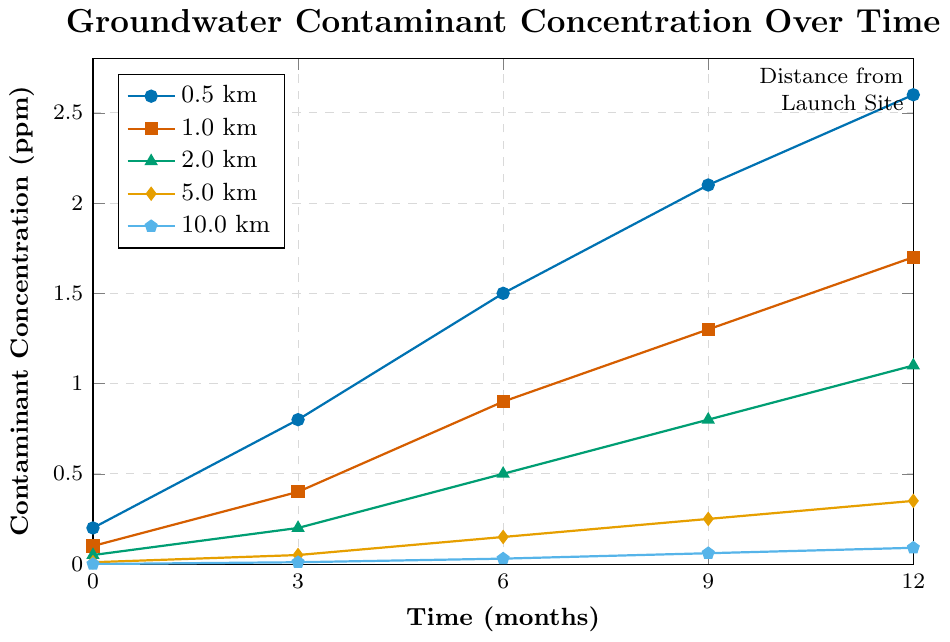What's the highest contaminant concentration at 0.5 km distance? Look at the line marked for 0.5 km distance and find the highest data point, which is at 12 months. This point shows the value of 2.6 ppm.
Answer: 2.6 ppm What is the difference in contaminant concentration between the 0.5 km and 1.0 km distances at 12 months? Look at the data points at 12 months for both 0.5 km and 1.0 km distances. The values are 2.6 ppm and 1.7 ppm, respectively. Subtract the latter from the former: 2.6 - 1.7 = 0.9.
Answer: 0.9 ppm Which distance shows the least increase in contaminant concentration over the 12 months? Calculate the increase for each distance from 0 to 12 months. 0.5 km: 2.6-0.2=2.4, 1.0 km: 1.7-0.1=1.6, 2.0 km: 1.1-0.05=1.05, 5.0 km: 0.35-0.01=0.34, 10.0 km: 0.09-0=0.09. The smallest increase is at 10.0 km.
Answer: 10.0 km Is there any distance where contaminant concentration decreases over time? All lines show an increase in contaminant concentration over time. None of the distances show a decrease.
Answer: No Which distance has a contaminant concentration of approximately 0.8 ppm at 9 months? Look at the data points at 9 months for all distances. Only 2.0 km has a contaminant concentration close to 0.8 ppm.
Answer: 2.0 km How many times does the contaminant concentration at 0.5 km increase from 0 months to 12 months? The concentration at 0.5 km is 0.2 ppm at 0 months and 2.6 ppm at 12 months. Divide the final value by the initial value: 2.6 / 0.2 = 13.
Answer: 13 times At what distance does the concentration reach 1.1 ppm at 12 months? Look at the data points at 12 months and find the distance where the concentration is 1.1 ppm, which is at 2.0 km.
Answer: 2.0 km Between 1.0 km and 5.0 km, which distance has the greater contaminant concentration at 6 months? Look at the data points at 6 months for 1.0 km and 5.0 km. The concentrations are 0.9 ppm for 1.0 km and 0.15 ppm for 5.0 km. Thus, 1.0 km is greater.
Answer: 1.0 km By how much does the concentration at 2.0 km increase from 3 months to 9 months? The concentration at 2.0 km is 0.2 ppm at 3 months and 0.8 ppm at 9 months. Subtract the former from the latter: 0.8 - 0.2 = 0.6.
Answer: 0.6 ppm Which distance shows the most similar pattern of increase to 5.0 km? Compare the patterns of increase for different distances. Find the one most similar to 5.0 km by assessing the rate and shape of growth, which is 10.0 km. Both show a gradual and small increase.
Answer: 10.0 km 